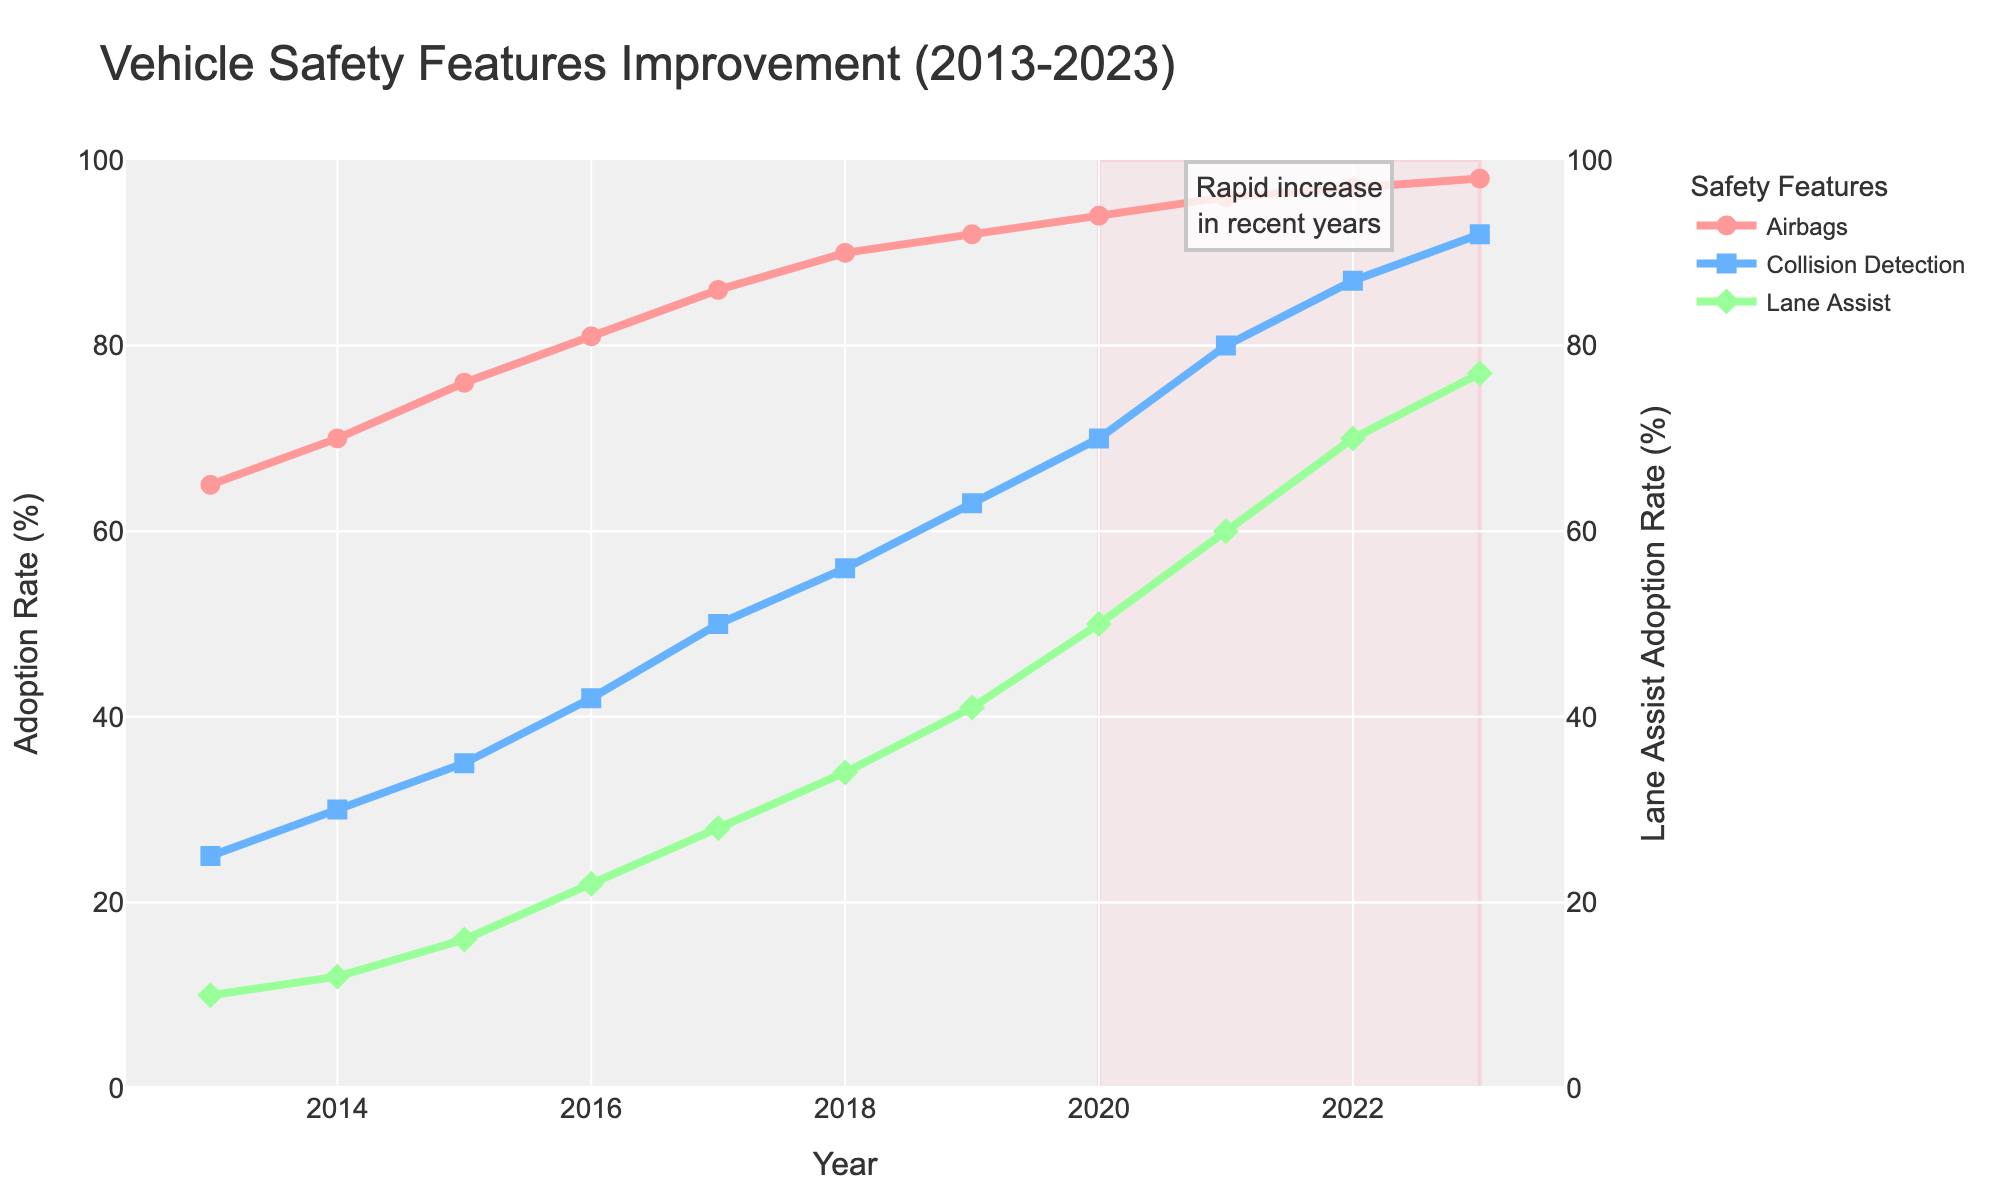What is the title of the figure? The title is displayed at the top center of the figure. It shows the main topic of the figure related to vehicle safety features.
Answer: Vehicle Safety Features Improvement (2013-2023) Which safety feature had the highest adoption rate in 2013? To find this, look at the starting points of each line on the graph for the year 2013. Compare the percentages for Airbags, Collision Detection, and Lane Assist.
Answer: Airbags What is the adoption rate of Lane Assist in 2020? Locate the year 2020 on the x-axis and follow the line for Lane Assist upwards to the corresponding y-axis value.
Answer: 50% Which safety feature had the most rapid increase in adoption rate from 2020 to 2023? Examine the slopes of each line for Airbags, Collision Detection, and Lane Assist between 2020 and 2023. The line with the steepest upward slope indicates the most rapid increase.
Answer: Collision Detection How much did the adoption rate of Collision Detection increase between 2014 and 2019? Calculate the difference between the Collision Detection rates in 2019 and 2014 by subtracting the 2014 rate from the 2019 rate.
Answer: 38% By how many percentage points did the Collision Detection adoption rate grow from 2013 to 2023? Find the rate for Collision Detection in both 2013 and 2023, then subtract the 2013 rate from the 2023 rate to find the difference in percentage points.
Answer: 67% In which year did Airbags adoption rate exceed 90%? Check the y-values of the Airbags line to see when it first crosses the 90% mark on the y-axis.
Answer: 2018 Which safety feature had the slowest growth between 2013 and 2023? Compare the overall increase in adoption rates from 2013 to 2023 for each feature. The feature with the smallest total increase had the slowest growth.
Answer: Lane Assist How did the adoption rates of Airbags and Lane Assist compare in 2015? Locate the year 2015 on the x-axis and find the corresponding y-values for both Airbags and Lane Assist. Compare the two rates.
Answer: Airbags had a much higher rate than Lane Assist What trend is highlighted in the annotated area of the plot? The annotation text and the highlighted rectangular area underline a specific trend observed. It points out the rapid increase in recent years.
Answer: Rapid increase 